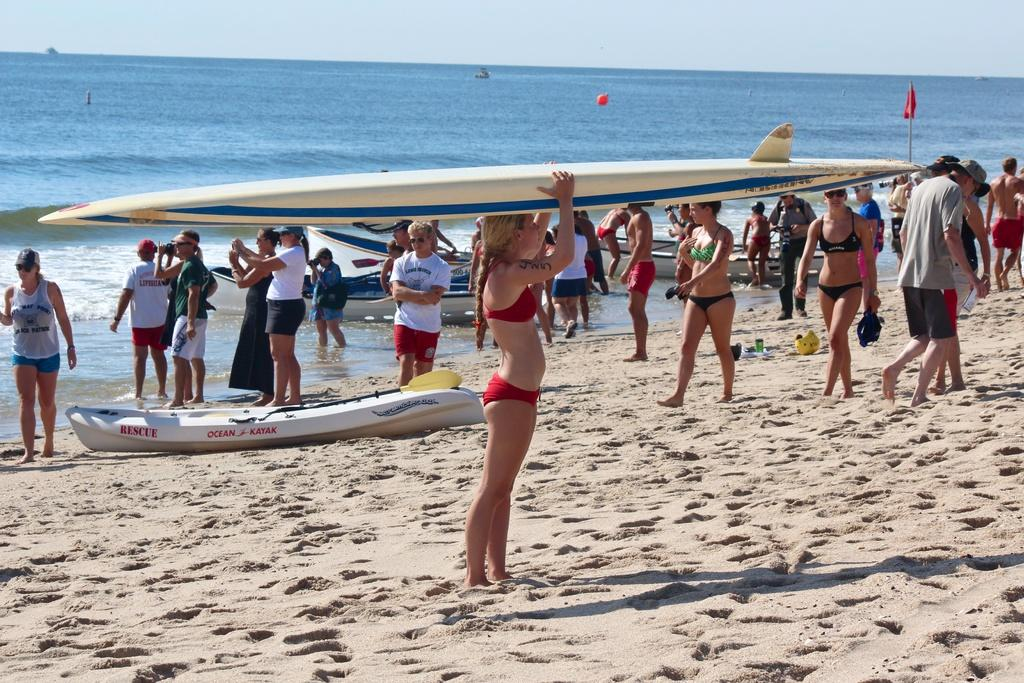What is the main setting of the image? There is a sea in the image. What can be seen in front of the sea? There are boats and a group of persons in front of the sea. Can you describe the woman in the foreground of the image? The woman in the foreground of the image is holding a ski board on her head. What type of bun is the woman holding in the image? There is no bun present in the image; the woman is holding a ski board on her head. What experience does the woman have with skiing based on the image? The image does not provide any information about the woman's experience with skiing. 